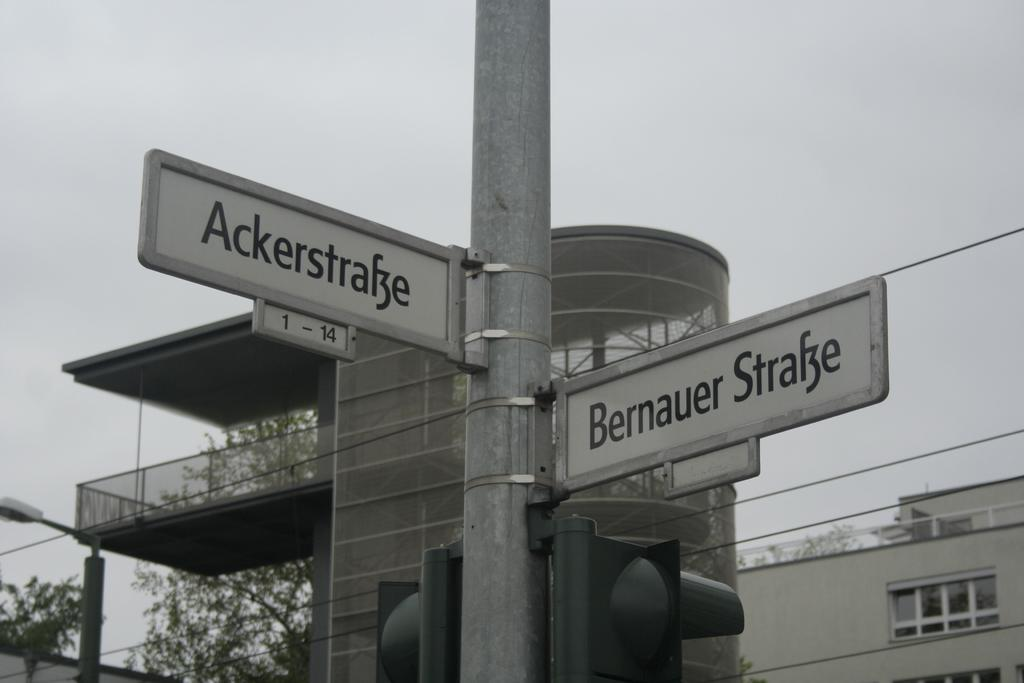<image>
Share a concise interpretation of the image provided. Some street signs, one of which points to Bernauer Strafze 